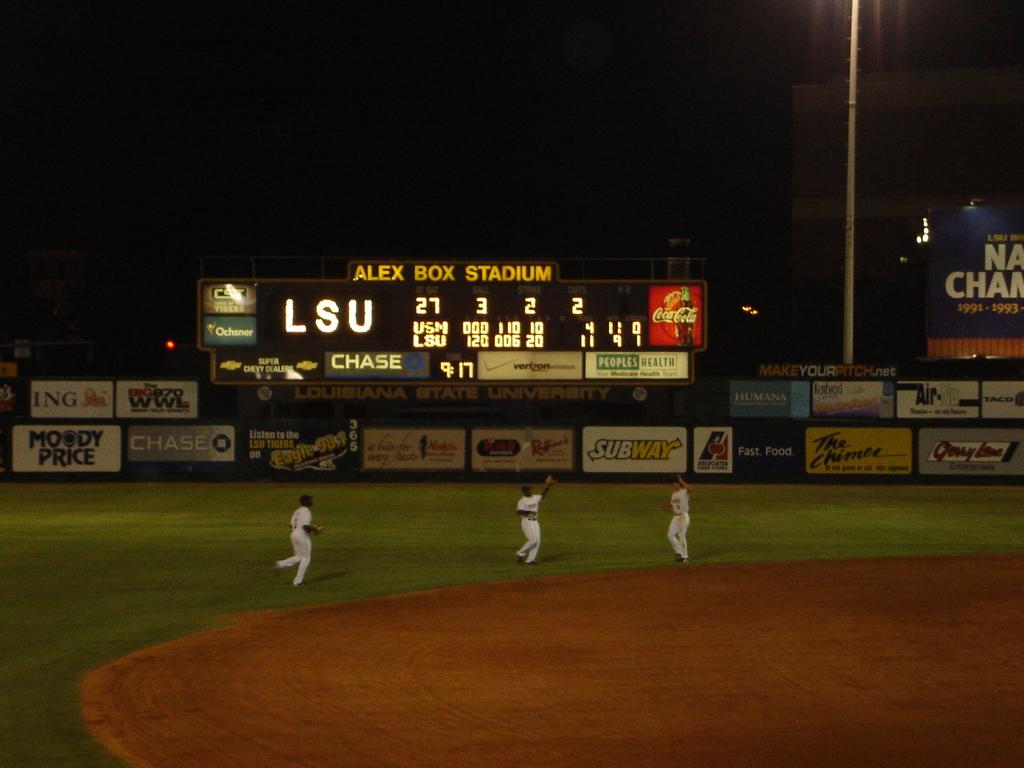Team play the cricket?
Provide a short and direct response. Answering does not require reading text in the image. 